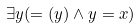Convert formula to latex. <formula><loc_0><loc_0><loc_500><loc_500>\exists y ( = ( y ) \wedge y = x )</formula> 